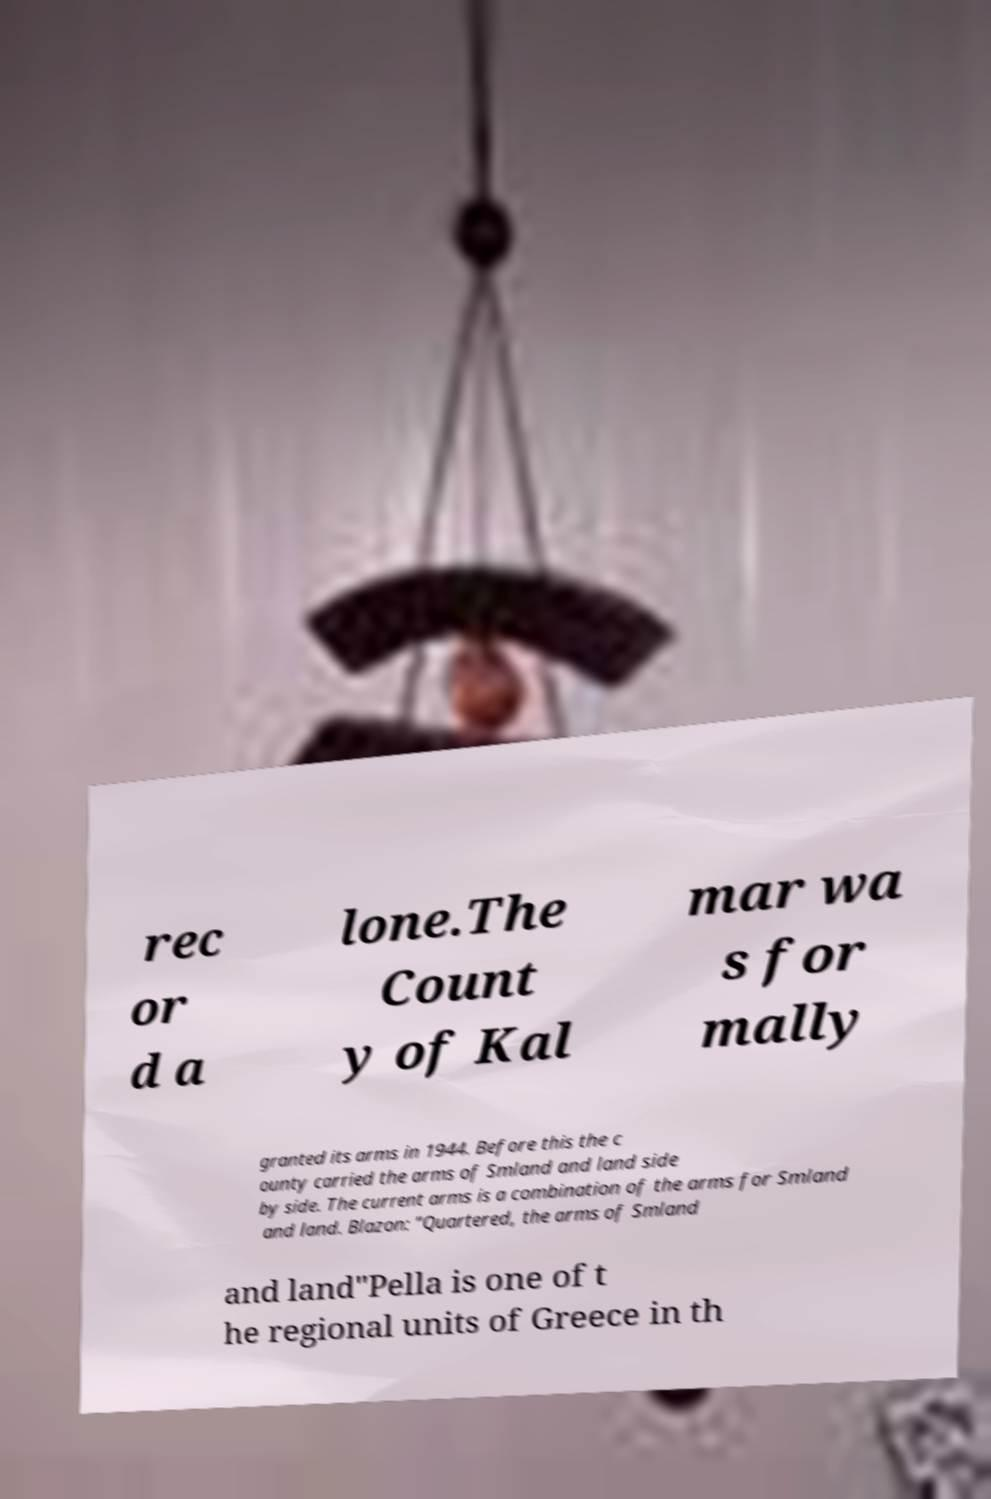Could you assist in decoding the text presented in this image and type it out clearly? rec or d a lone.The Count y of Kal mar wa s for mally granted its arms in 1944. Before this the c ounty carried the arms of Smland and land side by side. The current arms is a combination of the arms for Smland and land. Blazon: "Quartered, the arms of Smland and land"Pella is one of t he regional units of Greece in th 